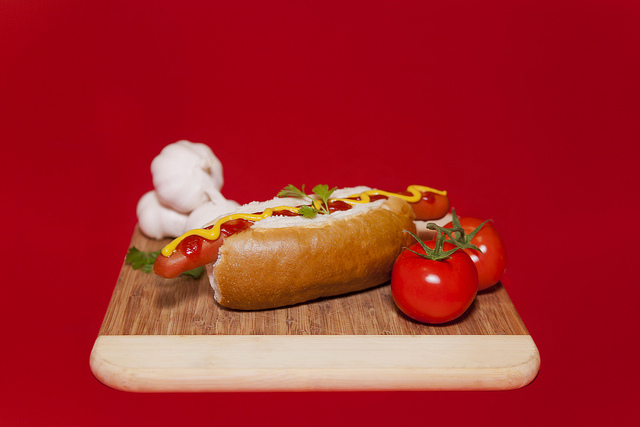What are the green things? The green elements visible in the image are fresh parsley leaves used as a garnish for the hot dog. 